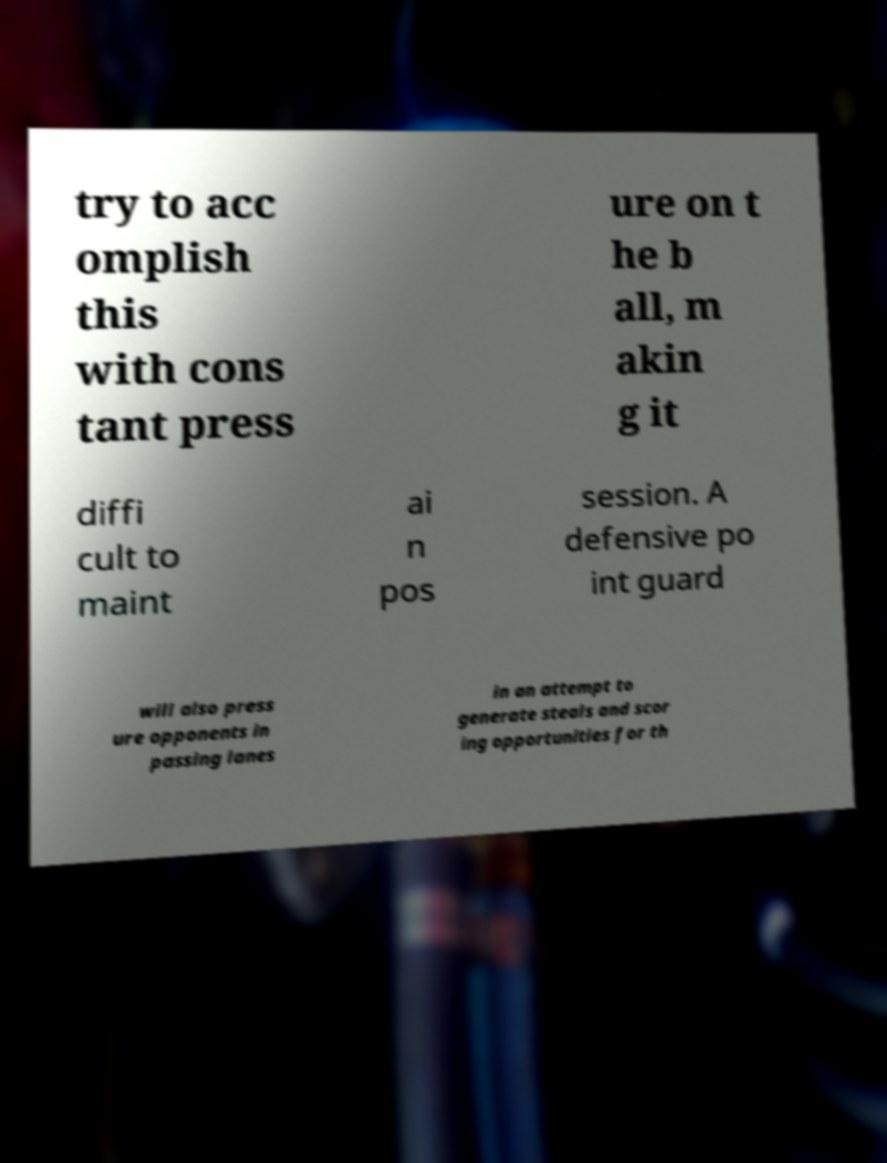Please identify and transcribe the text found in this image. try to acc omplish this with cons tant press ure on t he b all, m akin g it diffi cult to maint ai n pos session. A defensive po int guard will also press ure opponents in passing lanes in an attempt to generate steals and scor ing opportunities for th 